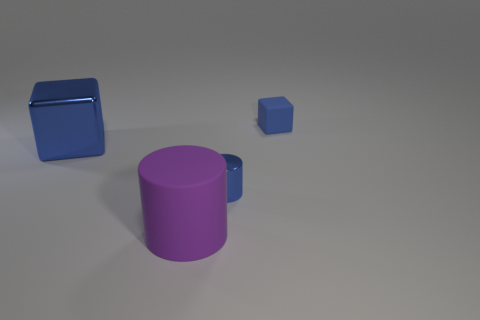What number of shiny things are behind the blue object that is behind the metallic object to the left of the big cylinder? There are no shiny objects located behind the blue object that sits behind the metallic object to the left of the large cylinder. The picture shows a clear area with no shiny items in that specific location. 